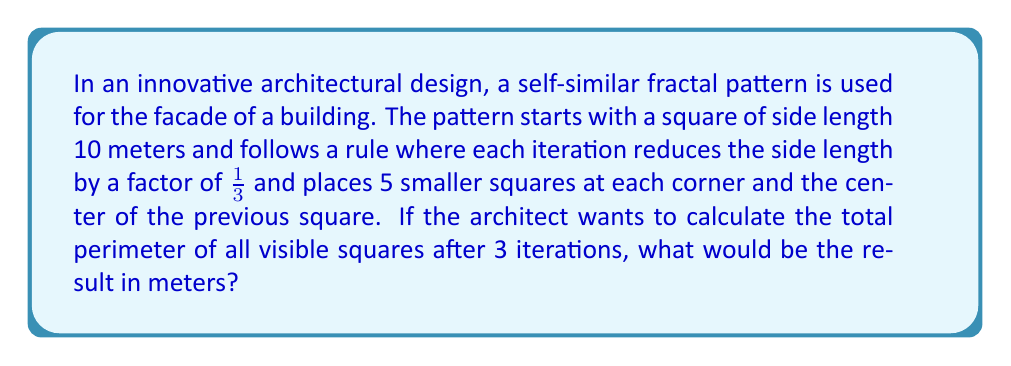What is the answer to this math problem? Let's break this down step-by-step:

1) First, let's calculate the side length of the squares at each iteration:
   Iteration 0 (initial): $10$ meters
   Iteration 1: $10 \cdot \frac{1}{3} = \frac{10}{3}$ meters
   Iteration 2: $\frac{10}{3} \cdot \frac{1}{3} = \frac{10}{9}$ meters
   Iteration 3: $\frac{10}{9} \cdot \frac{1}{3} = \frac{10}{27}$ meters

2) Now, let's count the number of squares at each iteration:
   Iteration 0: 1 square
   Iteration 1: 1 + 5 = 6 squares
   Iteration 2: 6 + 5 * 5 = 31 squares
   Iteration 3: 31 + 25 * 5 = 156 squares

3) Calculate the perimeter of squares at each iteration:
   Iteration 0: $1 \cdot (4 \cdot 10) = 40$ meters
   Iteration 1: $5 \cdot (4 \cdot \frac{10}{3}) = \frac{200}{3}$ meters
   Iteration 2: $25 \cdot (4 \cdot \frac{10}{9}) = \frac{1000}{9}$ meters
   Iteration 3: $125 \cdot (4 \cdot \frac{10}{27}) = \frac{5000}{27}$ meters

4) Sum up all the perimeters:

   Total perimeter = $40 + \frac{200}{3} + \frac{1000}{9} + \frac{5000}{27}$

5) Find a common denominator (27) and add:

   $\frac{1080}{27} + \frac{1800}{27} + \frac{3000}{27} + \frac{5000}{27} = \frac{10880}{27}$

6) Simplify:

   $\frac{10880}{27} = 402.96296...$ meters

Therefore, the total perimeter of all visible squares after 3 iterations is approximately 402.96 meters.
Answer: 402.96 meters 